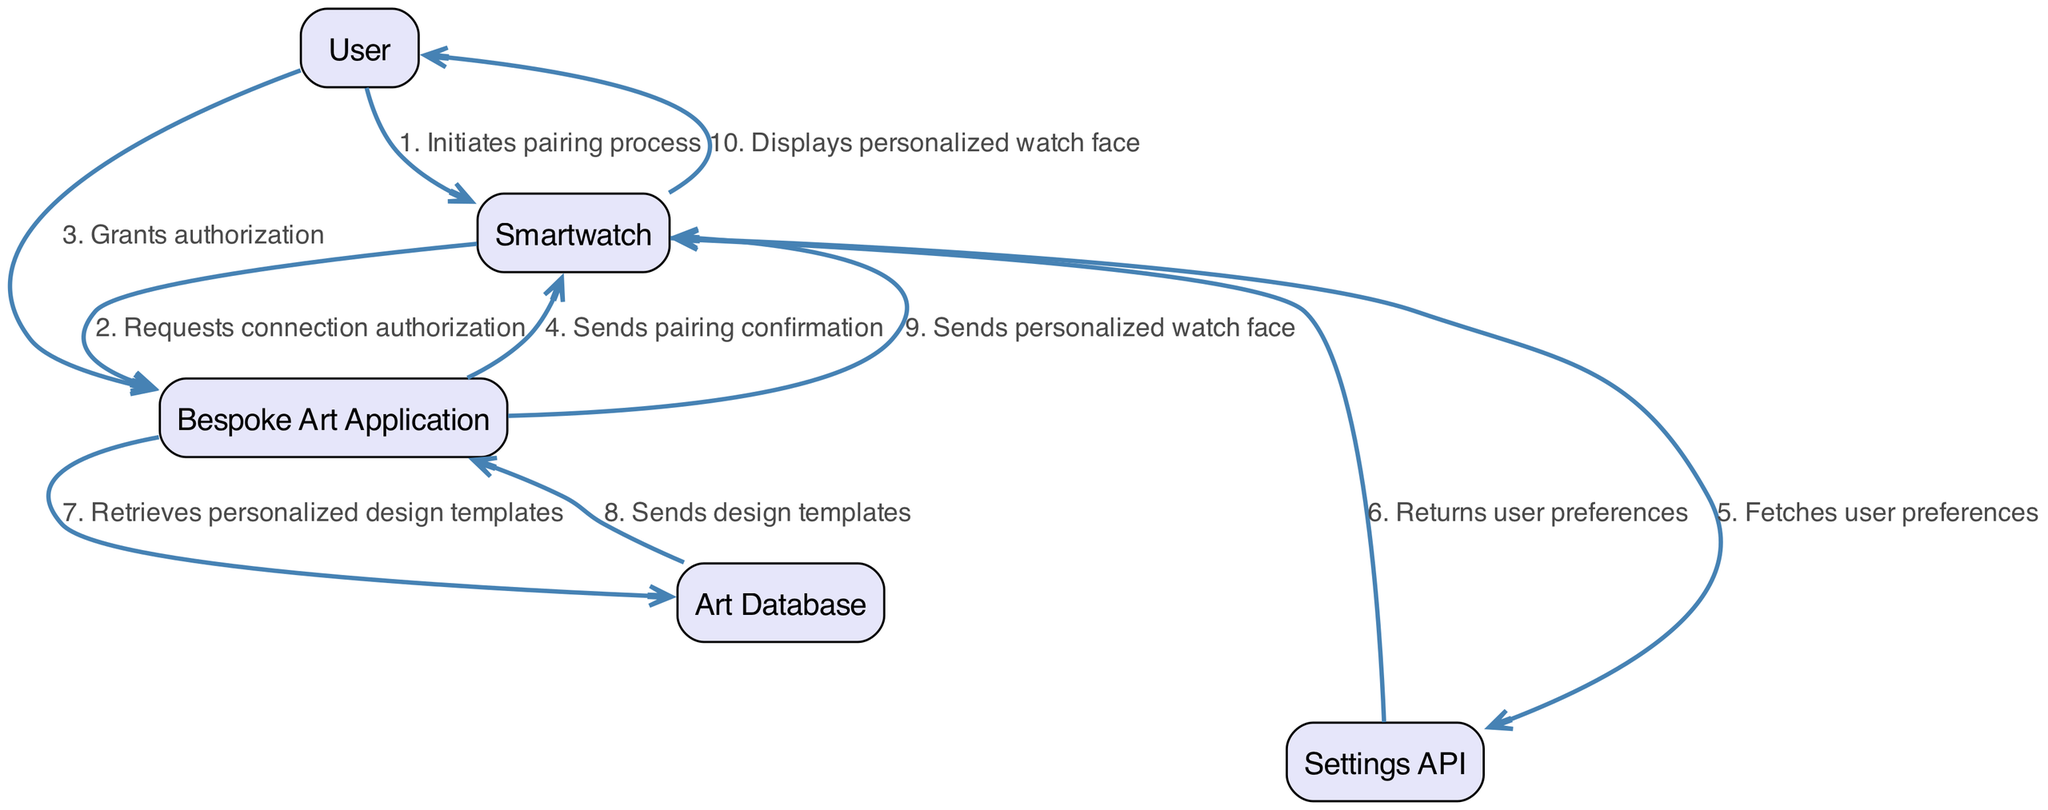What is the first action in the sequence? The first action is initiated by the User who starts the pairing process with the Smartwatch. This is the initial step of the diagram, marking the beginning of the sequence.
Answer: Initiates pairing process How many participants are involved in the sequence? The diagram features five distinct participants: User, Smartwatch, Bespoke Art Application, Art Database, and Settings API.
Answer: Five Who requests connection authorization? The Smartwatch is the entity that sends a request for connection authorization to the Bespoke Art Application after the User initiates the pairing process, as indicated by the arrows in the diagram.
Answer: Smartwatch What does the Bespoke Art Application do after receiving authorization? Once authorization is granted by the User, the Bespoke Art Application sends a pairing confirmation back to the Smartwatch, completing the authorization step in the sequence.
Answer: Sends pairing confirmation Which component fetches user preferences? The Smartwatch fetches user preferences by communicating with the Settings API, indicating that the Smartwatch is responsible for retrieving this specific information as outlined in the steps.
Answer: Smartwatch How many steps are there in the sequence? The diagram contains a total of ten steps, outlining the various interactions and actions taken between the participants from start to finish in the pairing process.
Answer: Ten What action does the Art Database perform? The Art Database retrieves personalized design templates upon request from the Bespoke Art Application, which is a critical step in obtaining the relevant data needed for personalizing the watch face.
Answer: Retrieves personalized design templates In which step does the User see the personalized watch face? The User sees the personalized watch face in the final step of the sequence when the Smartwatch displays it after receiving the custom design from the Bespoke Art Application.
Answer: Displays personalized watch face How does the Bespoke Art Application obtain design templates? The Bespoke Art Application obtains design templates by sending a request to the Art Database, which fulfills this request by sending back the templates, forming a link between these two components.
Answer: Retrieves personalized design templates What is the last action taken in the sequence? The last action in the sequence is the Smartwatch displaying the personalized watch face to the User, marking the conclusion of the integration process.
Answer: Displays personalized watch face 